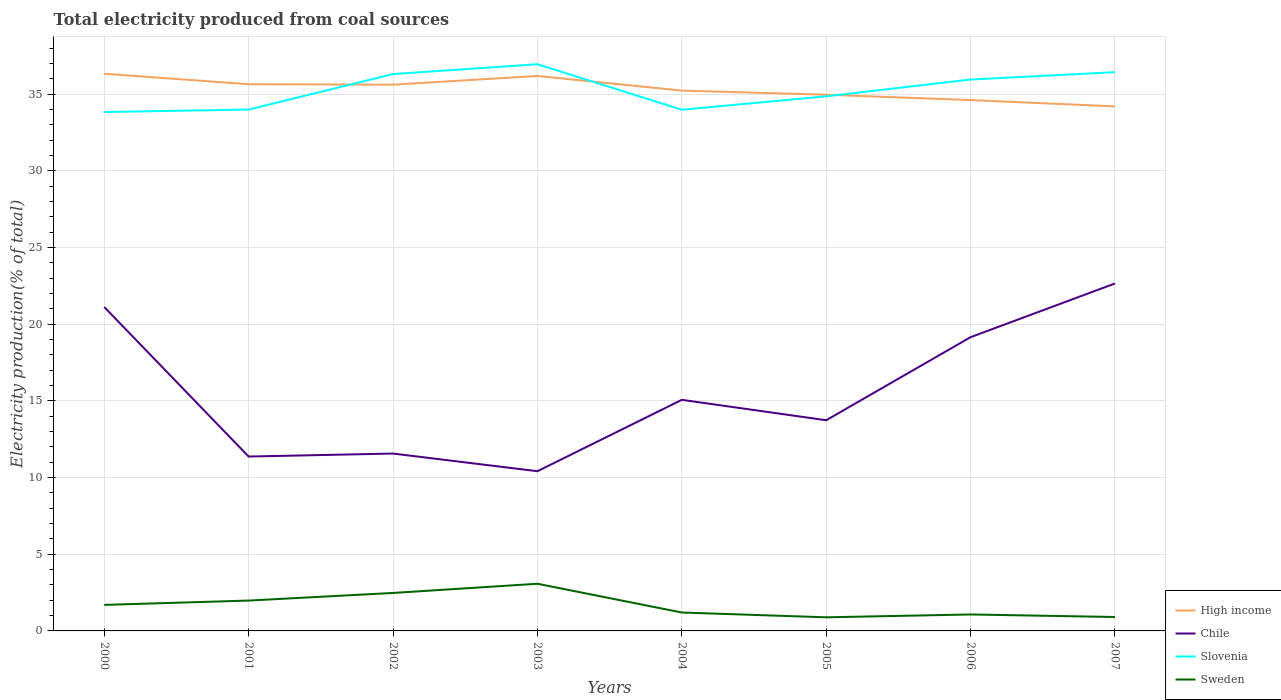Does the line corresponding to Chile intersect with the line corresponding to Sweden?
Ensure brevity in your answer.  No. Across all years, what is the maximum total electricity produced in Chile?
Your response must be concise. 10.42. In which year was the total electricity produced in Sweden maximum?
Your answer should be very brief. 2005. What is the total total electricity produced in Slovenia in the graph?
Provide a short and direct response. -1.97. What is the difference between the highest and the second highest total electricity produced in Chile?
Provide a short and direct response. 12.24. What is the difference between the highest and the lowest total electricity produced in Slovenia?
Provide a short and direct response. 4. Is the total electricity produced in Sweden strictly greater than the total electricity produced in Chile over the years?
Your answer should be very brief. Yes. Does the graph contain any zero values?
Provide a succinct answer. No. Where does the legend appear in the graph?
Your response must be concise. Bottom right. What is the title of the graph?
Provide a succinct answer. Total electricity produced from coal sources. Does "Uganda" appear as one of the legend labels in the graph?
Give a very brief answer. No. What is the Electricity production(% of total) of High income in 2000?
Provide a short and direct response. 36.34. What is the Electricity production(% of total) of Chile in 2000?
Make the answer very short. 21.13. What is the Electricity production(% of total) of Slovenia in 2000?
Your response must be concise. 33.84. What is the Electricity production(% of total) in Sweden in 2000?
Give a very brief answer. 1.7. What is the Electricity production(% of total) in High income in 2001?
Ensure brevity in your answer.  35.66. What is the Electricity production(% of total) of Chile in 2001?
Give a very brief answer. 11.37. What is the Electricity production(% of total) of Slovenia in 2001?
Your answer should be very brief. 34. What is the Electricity production(% of total) of Sweden in 2001?
Make the answer very short. 1.98. What is the Electricity production(% of total) in High income in 2002?
Give a very brief answer. 35.63. What is the Electricity production(% of total) of Chile in 2002?
Your answer should be compact. 11.57. What is the Electricity production(% of total) in Slovenia in 2002?
Make the answer very short. 36.32. What is the Electricity production(% of total) in Sweden in 2002?
Provide a succinct answer. 2.48. What is the Electricity production(% of total) in High income in 2003?
Your response must be concise. 36.2. What is the Electricity production(% of total) in Chile in 2003?
Offer a very short reply. 10.42. What is the Electricity production(% of total) of Slovenia in 2003?
Offer a very short reply. 36.96. What is the Electricity production(% of total) of Sweden in 2003?
Your answer should be compact. 3.08. What is the Electricity production(% of total) of High income in 2004?
Offer a terse response. 35.24. What is the Electricity production(% of total) in Chile in 2004?
Ensure brevity in your answer.  15.07. What is the Electricity production(% of total) of Slovenia in 2004?
Make the answer very short. 33.99. What is the Electricity production(% of total) in Sweden in 2004?
Keep it short and to the point. 1.2. What is the Electricity production(% of total) of High income in 2005?
Your response must be concise. 34.97. What is the Electricity production(% of total) of Chile in 2005?
Give a very brief answer. 13.74. What is the Electricity production(% of total) in Slovenia in 2005?
Your response must be concise. 34.87. What is the Electricity production(% of total) of Sweden in 2005?
Ensure brevity in your answer.  0.89. What is the Electricity production(% of total) in High income in 2006?
Your answer should be very brief. 34.62. What is the Electricity production(% of total) of Chile in 2006?
Offer a very short reply. 19.16. What is the Electricity production(% of total) of Slovenia in 2006?
Your answer should be very brief. 35.96. What is the Electricity production(% of total) of Sweden in 2006?
Give a very brief answer. 1.07. What is the Electricity production(% of total) in High income in 2007?
Provide a succinct answer. 34.21. What is the Electricity production(% of total) of Chile in 2007?
Provide a succinct answer. 22.66. What is the Electricity production(% of total) in Slovenia in 2007?
Give a very brief answer. 36.44. What is the Electricity production(% of total) of Sweden in 2007?
Your answer should be very brief. 0.91. Across all years, what is the maximum Electricity production(% of total) of High income?
Your response must be concise. 36.34. Across all years, what is the maximum Electricity production(% of total) of Chile?
Keep it short and to the point. 22.66. Across all years, what is the maximum Electricity production(% of total) of Slovenia?
Provide a short and direct response. 36.96. Across all years, what is the maximum Electricity production(% of total) in Sweden?
Offer a very short reply. 3.08. Across all years, what is the minimum Electricity production(% of total) in High income?
Make the answer very short. 34.21. Across all years, what is the minimum Electricity production(% of total) of Chile?
Your response must be concise. 10.42. Across all years, what is the minimum Electricity production(% of total) of Slovenia?
Your answer should be compact. 33.84. Across all years, what is the minimum Electricity production(% of total) of Sweden?
Ensure brevity in your answer.  0.89. What is the total Electricity production(% of total) of High income in the graph?
Keep it short and to the point. 282.87. What is the total Electricity production(% of total) in Chile in the graph?
Your response must be concise. 125.12. What is the total Electricity production(% of total) in Slovenia in the graph?
Give a very brief answer. 282.4. What is the total Electricity production(% of total) of Sweden in the graph?
Provide a succinct answer. 13.3. What is the difference between the Electricity production(% of total) of High income in 2000 and that in 2001?
Your answer should be compact. 0.68. What is the difference between the Electricity production(% of total) in Chile in 2000 and that in 2001?
Offer a very short reply. 9.75. What is the difference between the Electricity production(% of total) in Slovenia in 2000 and that in 2001?
Provide a succinct answer. -0.16. What is the difference between the Electricity production(% of total) in Sweden in 2000 and that in 2001?
Your answer should be very brief. -0.28. What is the difference between the Electricity production(% of total) in High income in 2000 and that in 2002?
Provide a succinct answer. 0.71. What is the difference between the Electricity production(% of total) in Chile in 2000 and that in 2002?
Your answer should be very brief. 9.56. What is the difference between the Electricity production(% of total) of Slovenia in 2000 and that in 2002?
Offer a very short reply. -2.48. What is the difference between the Electricity production(% of total) of Sweden in 2000 and that in 2002?
Provide a succinct answer. -0.78. What is the difference between the Electricity production(% of total) in High income in 2000 and that in 2003?
Provide a succinct answer. 0.14. What is the difference between the Electricity production(% of total) in Chile in 2000 and that in 2003?
Your answer should be compact. 10.71. What is the difference between the Electricity production(% of total) in Slovenia in 2000 and that in 2003?
Provide a short and direct response. -3.12. What is the difference between the Electricity production(% of total) of Sweden in 2000 and that in 2003?
Ensure brevity in your answer.  -1.38. What is the difference between the Electricity production(% of total) in High income in 2000 and that in 2004?
Your answer should be very brief. 1.1. What is the difference between the Electricity production(% of total) of Chile in 2000 and that in 2004?
Your response must be concise. 6.05. What is the difference between the Electricity production(% of total) in Slovenia in 2000 and that in 2004?
Provide a succinct answer. -0.15. What is the difference between the Electricity production(% of total) in Sweden in 2000 and that in 2004?
Your answer should be compact. 0.5. What is the difference between the Electricity production(% of total) in High income in 2000 and that in 2005?
Your response must be concise. 1.37. What is the difference between the Electricity production(% of total) in Chile in 2000 and that in 2005?
Make the answer very short. 7.38. What is the difference between the Electricity production(% of total) of Slovenia in 2000 and that in 2005?
Your response must be concise. -1.02. What is the difference between the Electricity production(% of total) of Sweden in 2000 and that in 2005?
Keep it short and to the point. 0.81. What is the difference between the Electricity production(% of total) in High income in 2000 and that in 2006?
Offer a very short reply. 1.72. What is the difference between the Electricity production(% of total) of Chile in 2000 and that in 2006?
Provide a succinct answer. 1.97. What is the difference between the Electricity production(% of total) of Slovenia in 2000 and that in 2006?
Your answer should be compact. -2.12. What is the difference between the Electricity production(% of total) in Sweden in 2000 and that in 2006?
Provide a short and direct response. 0.63. What is the difference between the Electricity production(% of total) of High income in 2000 and that in 2007?
Offer a terse response. 2.13. What is the difference between the Electricity production(% of total) of Chile in 2000 and that in 2007?
Give a very brief answer. -1.54. What is the difference between the Electricity production(% of total) in Slovenia in 2000 and that in 2007?
Provide a short and direct response. -2.6. What is the difference between the Electricity production(% of total) of Sweden in 2000 and that in 2007?
Ensure brevity in your answer.  0.79. What is the difference between the Electricity production(% of total) of High income in 2001 and that in 2002?
Keep it short and to the point. 0.03. What is the difference between the Electricity production(% of total) in Chile in 2001 and that in 2002?
Keep it short and to the point. -0.2. What is the difference between the Electricity production(% of total) in Slovenia in 2001 and that in 2002?
Provide a short and direct response. -2.32. What is the difference between the Electricity production(% of total) in Sweden in 2001 and that in 2002?
Keep it short and to the point. -0.5. What is the difference between the Electricity production(% of total) of High income in 2001 and that in 2003?
Offer a very short reply. -0.54. What is the difference between the Electricity production(% of total) of Chile in 2001 and that in 2003?
Ensure brevity in your answer.  0.96. What is the difference between the Electricity production(% of total) in Slovenia in 2001 and that in 2003?
Offer a terse response. -2.96. What is the difference between the Electricity production(% of total) of Sweden in 2001 and that in 2003?
Provide a short and direct response. -1.1. What is the difference between the Electricity production(% of total) in High income in 2001 and that in 2004?
Your answer should be very brief. 0.42. What is the difference between the Electricity production(% of total) in Chile in 2001 and that in 2004?
Keep it short and to the point. -3.7. What is the difference between the Electricity production(% of total) in Slovenia in 2001 and that in 2004?
Your answer should be very brief. 0.01. What is the difference between the Electricity production(% of total) of Sweden in 2001 and that in 2004?
Ensure brevity in your answer.  0.78. What is the difference between the Electricity production(% of total) in High income in 2001 and that in 2005?
Provide a succinct answer. 0.69. What is the difference between the Electricity production(% of total) in Chile in 2001 and that in 2005?
Your answer should be compact. -2.37. What is the difference between the Electricity production(% of total) in Slovenia in 2001 and that in 2005?
Ensure brevity in your answer.  -0.86. What is the difference between the Electricity production(% of total) of Sweden in 2001 and that in 2005?
Keep it short and to the point. 1.09. What is the difference between the Electricity production(% of total) of High income in 2001 and that in 2006?
Keep it short and to the point. 1.04. What is the difference between the Electricity production(% of total) of Chile in 2001 and that in 2006?
Your response must be concise. -7.79. What is the difference between the Electricity production(% of total) of Slovenia in 2001 and that in 2006?
Your response must be concise. -1.96. What is the difference between the Electricity production(% of total) of Sweden in 2001 and that in 2006?
Make the answer very short. 0.91. What is the difference between the Electricity production(% of total) in High income in 2001 and that in 2007?
Offer a very short reply. 1.45. What is the difference between the Electricity production(% of total) in Chile in 2001 and that in 2007?
Your response must be concise. -11.29. What is the difference between the Electricity production(% of total) of Slovenia in 2001 and that in 2007?
Your response must be concise. -2.44. What is the difference between the Electricity production(% of total) of Sweden in 2001 and that in 2007?
Offer a very short reply. 1.07. What is the difference between the Electricity production(% of total) in High income in 2002 and that in 2003?
Ensure brevity in your answer.  -0.57. What is the difference between the Electricity production(% of total) in Chile in 2002 and that in 2003?
Offer a terse response. 1.15. What is the difference between the Electricity production(% of total) of Slovenia in 2002 and that in 2003?
Provide a succinct answer. -0.64. What is the difference between the Electricity production(% of total) of Sweden in 2002 and that in 2003?
Offer a very short reply. -0.6. What is the difference between the Electricity production(% of total) in High income in 2002 and that in 2004?
Make the answer very short. 0.39. What is the difference between the Electricity production(% of total) in Chile in 2002 and that in 2004?
Ensure brevity in your answer.  -3.5. What is the difference between the Electricity production(% of total) in Slovenia in 2002 and that in 2004?
Your answer should be compact. 2.33. What is the difference between the Electricity production(% of total) in Sweden in 2002 and that in 2004?
Offer a terse response. 1.28. What is the difference between the Electricity production(% of total) of High income in 2002 and that in 2005?
Keep it short and to the point. 0.66. What is the difference between the Electricity production(% of total) of Chile in 2002 and that in 2005?
Ensure brevity in your answer.  -2.17. What is the difference between the Electricity production(% of total) of Slovenia in 2002 and that in 2005?
Your answer should be compact. 1.45. What is the difference between the Electricity production(% of total) in Sweden in 2002 and that in 2005?
Your response must be concise. 1.59. What is the difference between the Electricity production(% of total) of High income in 2002 and that in 2006?
Keep it short and to the point. 1. What is the difference between the Electricity production(% of total) of Chile in 2002 and that in 2006?
Provide a succinct answer. -7.59. What is the difference between the Electricity production(% of total) of Slovenia in 2002 and that in 2006?
Keep it short and to the point. 0.36. What is the difference between the Electricity production(% of total) in Sweden in 2002 and that in 2006?
Keep it short and to the point. 1.4. What is the difference between the Electricity production(% of total) in High income in 2002 and that in 2007?
Provide a short and direct response. 1.42. What is the difference between the Electricity production(% of total) of Chile in 2002 and that in 2007?
Ensure brevity in your answer.  -11.09. What is the difference between the Electricity production(% of total) in Slovenia in 2002 and that in 2007?
Your response must be concise. -0.12. What is the difference between the Electricity production(% of total) in Sweden in 2002 and that in 2007?
Your answer should be very brief. 1.57. What is the difference between the Electricity production(% of total) of High income in 2003 and that in 2004?
Ensure brevity in your answer.  0.95. What is the difference between the Electricity production(% of total) of Chile in 2003 and that in 2004?
Make the answer very short. -4.66. What is the difference between the Electricity production(% of total) of Slovenia in 2003 and that in 2004?
Keep it short and to the point. 2.97. What is the difference between the Electricity production(% of total) of Sweden in 2003 and that in 2004?
Provide a short and direct response. 1.88. What is the difference between the Electricity production(% of total) of High income in 2003 and that in 2005?
Your answer should be very brief. 1.22. What is the difference between the Electricity production(% of total) of Chile in 2003 and that in 2005?
Make the answer very short. -3.32. What is the difference between the Electricity production(% of total) in Slovenia in 2003 and that in 2005?
Ensure brevity in your answer.  2.09. What is the difference between the Electricity production(% of total) in Sweden in 2003 and that in 2005?
Your answer should be very brief. 2.19. What is the difference between the Electricity production(% of total) of High income in 2003 and that in 2006?
Ensure brevity in your answer.  1.57. What is the difference between the Electricity production(% of total) of Chile in 2003 and that in 2006?
Offer a very short reply. -8.74. What is the difference between the Electricity production(% of total) of Slovenia in 2003 and that in 2006?
Offer a very short reply. 1. What is the difference between the Electricity production(% of total) of Sweden in 2003 and that in 2006?
Provide a short and direct response. 2. What is the difference between the Electricity production(% of total) of High income in 2003 and that in 2007?
Give a very brief answer. 1.99. What is the difference between the Electricity production(% of total) of Chile in 2003 and that in 2007?
Offer a very short reply. -12.24. What is the difference between the Electricity production(% of total) of Slovenia in 2003 and that in 2007?
Offer a very short reply. 0.52. What is the difference between the Electricity production(% of total) in Sweden in 2003 and that in 2007?
Provide a short and direct response. 2.17. What is the difference between the Electricity production(% of total) of High income in 2004 and that in 2005?
Your answer should be very brief. 0.27. What is the difference between the Electricity production(% of total) in Chile in 2004 and that in 2005?
Your response must be concise. 1.33. What is the difference between the Electricity production(% of total) of Slovenia in 2004 and that in 2005?
Provide a succinct answer. -0.88. What is the difference between the Electricity production(% of total) of Sweden in 2004 and that in 2005?
Your response must be concise. 0.31. What is the difference between the Electricity production(% of total) in High income in 2004 and that in 2006?
Provide a short and direct response. 0.62. What is the difference between the Electricity production(% of total) in Chile in 2004 and that in 2006?
Ensure brevity in your answer.  -4.09. What is the difference between the Electricity production(% of total) of Slovenia in 2004 and that in 2006?
Provide a succinct answer. -1.97. What is the difference between the Electricity production(% of total) of Sweden in 2004 and that in 2006?
Your answer should be very brief. 0.13. What is the difference between the Electricity production(% of total) of High income in 2004 and that in 2007?
Give a very brief answer. 1.03. What is the difference between the Electricity production(% of total) of Chile in 2004 and that in 2007?
Make the answer very short. -7.59. What is the difference between the Electricity production(% of total) of Slovenia in 2004 and that in 2007?
Provide a succinct answer. -2.45. What is the difference between the Electricity production(% of total) of Sweden in 2004 and that in 2007?
Provide a short and direct response. 0.29. What is the difference between the Electricity production(% of total) of High income in 2005 and that in 2006?
Your answer should be compact. 0.35. What is the difference between the Electricity production(% of total) of Chile in 2005 and that in 2006?
Your response must be concise. -5.42. What is the difference between the Electricity production(% of total) of Slovenia in 2005 and that in 2006?
Give a very brief answer. -1.1. What is the difference between the Electricity production(% of total) of Sweden in 2005 and that in 2006?
Offer a terse response. -0.19. What is the difference between the Electricity production(% of total) of High income in 2005 and that in 2007?
Provide a succinct answer. 0.76. What is the difference between the Electricity production(% of total) of Chile in 2005 and that in 2007?
Offer a very short reply. -8.92. What is the difference between the Electricity production(% of total) in Slovenia in 2005 and that in 2007?
Your answer should be very brief. -1.57. What is the difference between the Electricity production(% of total) of Sweden in 2005 and that in 2007?
Provide a short and direct response. -0.02. What is the difference between the Electricity production(% of total) in High income in 2006 and that in 2007?
Make the answer very short. 0.41. What is the difference between the Electricity production(% of total) of Chile in 2006 and that in 2007?
Keep it short and to the point. -3.5. What is the difference between the Electricity production(% of total) of Slovenia in 2006 and that in 2007?
Ensure brevity in your answer.  -0.48. What is the difference between the Electricity production(% of total) in Sweden in 2006 and that in 2007?
Keep it short and to the point. 0.17. What is the difference between the Electricity production(% of total) of High income in 2000 and the Electricity production(% of total) of Chile in 2001?
Provide a succinct answer. 24.97. What is the difference between the Electricity production(% of total) in High income in 2000 and the Electricity production(% of total) in Slovenia in 2001?
Your answer should be compact. 2.34. What is the difference between the Electricity production(% of total) of High income in 2000 and the Electricity production(% of total) of Sweden in 2001?
Provide a succinct answer. 34.36. What is the difference between the Electricity production(% of total) in Chile in 2000 and the Electricity production(% of total) in Slovenia in 2001?
Your response must be concise. -12.88. What is the difference between the Electricity production(% of total) of Chile in 2000 and the Electricity production(% of total) of Sweden in 2001?
Make the answer very short. 19.15. What is the difference between the Electricity production(% of total) of Slovenia in 2000 and the Electricity production(% of total) of Sweden in 2001?
Your response must be concise. 31.86. What is the difference between the Electricity production(% of total) in High income in 2000 and the Electricity production(% of total) in Chile in 2002?
Your answer should be very brief. 24.77. What is the difference between the Electricity production(% of total) in High income in 2000 and the Electricity production(% of total) in Slovenia in 2002?
Provide a succinct answer. 0.02. What is the difference between the Electricity production(% of total) in High income in 2000 and the Electricity production(% of total) in Sweden in 2002?
Ensure brevity in your answer.  33.86. What is the difference between the Electricity production(% of total) of Chile in 2000 and the Electricity production(% of total) of Slovenia in 2002?
Provide a short and direct response. -15.19. What is the difference between the Electricity production(% of total) in Chile in 2000 and the Electricity production(% of total) in Sweden in 2002?
Provide a short and direct response. 18.65. What is the difference between the Electricity production(% of total) of Slovenia in 2000 and the Electricity production(% of total) of Sweden in 2002?
Your answer should be compact. 31.37. What is the difference between the Electricity production(% of total) in High income in 2000 and the Electricity production(% of total) in Chile in 2003?
Your answer should be compact. 25.92. What is the difference between the Electricity production(% of total) of High income in 2000 and the Electricity production(% of total) of Slovenia in 2003?
Your response must be concise. -0.62. What is the difference between the Electricity production(% of total) of High income in 2000 and the Electricity production(% of total) of Sweden in 2003?
Your answer should be compact. 33.26. What is the difference between the Electricity production(% of total) of Chile in 2000 and the Electricity production(% of total) of Slovenia in 2003?
Your answer should be very brief. -15.83. What is the difference between the Electricity production(% of total) of Chile in 2000 and the Electricity production(% of total) of Sweden in 2003?
Your answer should be compact. 18.05. What is the difference between the Electricity production(% of total) of Slovenia in 2000 and the Electricity production(% of total) of Sweden in 2003?
Your answer should be very brief. 30.77. What is the difference between the Electricity production(% of total) of High income in 2000 and the Electricity production(% of total) of Chile in 2004?
Make the answer very short. 21.27. What is the difference between the Electricity production(% of total) in High income in 2000 and the Electricity production(% of total) in Slovenia in 2004?
Make the answer very short. 2.35. What is the difference between the Electricity production(% of total) of High income in 2000 and the Electricity production(% of total) of Sweden in 2004?
Provide a succinct answer. 35.14. What is the difference between the Electricity production(% of total) of Chile in 2000 and the Electricity production(% of total) of Slovenia in 2004?
Keep it short and to the point. -12.87. What is the difference between the Electricity production(% of total) of Chile in 2000 and the Electricity production(% of total) of Sweden in 2004?
Ensure brevity in your answer.  19.93. What is the difference between the Electricity production(% of total) in Slovenia in 2000 and the Electricity production(% of total) in Sweden in 2004?
Offer a terse response. 32.64. What is the difference between the Electricity production(% of total) of High income in 2000 and the Electricity production(% of total) of Chile in 2005?
Offer a very short reply. 22.6. What is the difference between the Electricity production(% of total) of High income in 2000 and the Electricity production(% of total) of Slovenia in 2005?
Ensure brevity in your answer.  1.47. What is the difference between the Electricity production(% of total) of High income in 2000 and the Electricity production(% of total) of Sweden in 2005?
Make the answer very short. 35.45. What is the difference between the Electricity production(% of total) in Chile in 2000 and the Electricity production(% of total) in Slovenia in 2005?
Give a very brief answer. -13.74. What is the difference between the Electricity production(% of total) of Chile in 2000 and the Electricity production(% of total) of Sweden in 2005?
Keep it short and to the point. 20.24. What is the difference between the Electricity production(% of total) in Slovenia in 2000 and the Electricity production(% of total) in Sweden in 2005?
Ensure brevity in your answer.  32.96. What is the difference between the Electricity production(% of total) of High income in 2000 and the Electricity production(% of total) of Chile in 2006?
Ensure brevity in your answer.  17.18. What is the difference between the Electricity production(% of total) in High income in 2000 and the Electricity production(% of total) in Slovenia in 2006?
Your response must be concise. 0.38. What is the difference between the Electricity production(% of total) of High income in 2000 and the Electricity production(% of total) of Sweden in 2006?
Your answer should be compact. 35.27. What is the difference between the Electricity production(% of total) of Chile in 2000 and the Electricity production(% of total) of Slovenia in 2006?
Your response must be concise. -14.84. What is the difference between the Electricity production(% of total) in Chile in 2000 and the Electricity production(% of total) in Sweden in 2006?
Offer a terse response. 20.05. What is the difference between the Electricity production(% of total) in Slovenia in 2000 and the Electricity production(% of total) in Sweden in 2006?
Provide a succinct answer. 32.77. What is the difference between the Electricity production(% of total) of High income in 2000 and the Electricity production(% of total) of Chile in 2007?
Offer a terse response. 13.68. What is the difference between the Electricity production(% of total) in High income in 2000 and the Electricity production(% of total) in Slovenia in 2007?
Make the answer very short. -0.1. What is the difference between the Electricity production(% of total) of High income in 2000 and the Electricity production(% of total) of Sweden in 2007?
Provide a short and direct response. 35.43. What is the difference between the Electricity production(% of total) of Chile in 2000 and the Electricity production(% of total) of Slovenia in 2007?
Keep it short and to the point. -15.32. What is the difference between the Electricity production(% of total) of Chile in 2000 and the Electricity production(% of total) of Sweden in 2007?
Provide a short and direct response. 20.22. What is the difference between the Electricity production(% of total) in Slovenia in 2000 and the Electricity production(% of total) in Sweden in 2007?
Provide a short and direct response. 32.94. What is the difference between the Electricity production(% of total) in High income in 2001 and the Electricity production(% of total) in Chile in 2002?
Offer a terse response. 24.09. What is the difference between the Electricity production(% of total) of High income in 2001 and the Electricity production(% of total) of Slovenia in 2002?
Make the answer very short. -0.66. What is the difference between the Electricity production(% of total) of High income in 2001 and the Electricity production(% of total) of Sweden in 2002?
Offer a very short reply. 33.18. What is the difference between the Electricity production(% of total) in Chile in 2001 and the Electricity production(% of total) in Slovenia in 2002?
Make the answer very short. -24.95. What is the difference between the Electricity production(% of total) in Chile in 2001 and the Electricity production(% of total) in Sweden in 2002?
Your answer should be compact. 8.9. What is the difference between the Electricity production(% of total) in Slovenia in 2001 and the Electricity production(% of total) in Sweden in 2002?
Provide a succinct answer. 31.53. What is the difference between the Electricity production(% of total) in High income in 2001 and the Electricity production(% of total) in Chile in 2003?
Give a very brief answer. 25.24. What is the difference between the Electricity production(% of total) of High income in 2001 and the Electricity production(% of total) of Slovenia in 2003?
Keep it short and to the point. -1.3. What is the difference between the Electricity production(% of total) in High income in 2001 and the Electricity production(% of total) in Sweden in 2003?
Ensure brevity in your answer.  32.58. What is the difference between the Electricity production(% of total) in Chile in 2001 and the Electricity production(% of total) in Slovenia in 2003?
Provide a short and direct response. -25.59. What is the difference between the Electricity production(% of total) of Chile in 2001 and the Electricity production(% of total) of Sweden in 2003?
Keep it short and to the point. 8.3. What is the difference between the Electricity production(% of total) in Slovenia in 2001 and the Electricity production(% of total) in Sweden in 2003?
Give a very brief answer. 30.93. What is the difference between the Electricity production(% of total) of High income in 2001 and the Electricity production(% of total) of Chile in 2004?
Keep it short and to the point. 20.59. What is the difference between the Electricity production(% of total) of High income in 2001 and the Electricity production(% of total) of Slovenia in 2004?
Your answer should be compact. 1.67. What is the difference between the Electricity production(% of total) of High income in 2001 and the Electricity production(% of total) of Sweden in 2004?
Offer a terse response. 34.46. What is the difference between the Electricity production(% of total) in Chile in 2001 and the Electricity production(% of total) in Slovenia in 2004?
Your response must be concise. -22.62. What is the difference between the Electricity production(% of total) in Chile in 2001 and the Electricity production(% of total) in Sweden in 2004?
Provide a short and direct response. 10.17. What is the difference between the Electricity production(% of total) in Slovenia in 2001 and the Electricity production(% of total) in Sweden in 2004?
Your response must be concise. 32.8. What is the difference between the Electricity production(% of total) of High income in 2001 and the Electricity production(% of total) of Chile in 2005?
Provide a succinct answer. 21.92. What is the difference between the Electricity production(% of total) of High income in 2001 and the Electricity production(% of total) of Slovenia in 2005?
Ensure brevity in your answer.  0.79. What is the difference between the Electricity production(% of total) in High income in 2001 and the Electricity production(% of total) in Sweden in 2005?
Provide a succinct answer. 34.77. What is the difference between the Electricity production(% of total) of Chile in 2001 and the Electricity production(% of total) of Slovenia in 2005?
Provide a succinct answer. -23.5. What is the difference between the Electricity production(% of total) of Chile in 2001 and the Electricity production(% of total) of Sweden in 2005?
Keep it short and to the point. 10.49. What is the difference between the Electricity production(% of total) of Slovenia in 2001 and the Electricity production(% of total) of Sweden in 2005?
Offer a very short reply. 33.12. What is the difference between the Electricity production(% of total) of High income in 2001 and the Electricity production(% of total) of Chile in 2006?
Provide a succinct answer. 16.5. What is the difference between the Electricity production(% of total) of High income in 2001 and the Electricity production(% of total) of Slovenia in 2006?
Make the answer very short. -0.31. What is the difference between the Electricity production(% of total) in High income in 2001 and the Electricity production(% of total) in Sweden in 2006?
Provide a succinct answer. 34.59. What is the difference between the Electricity production(% of total) in Chile in 2001 and the Electricity production(% of total) in Slovenia in 2006?
Keep it short and to the point. -24.59. What is the difference between the Electricity production(% of total) in Chile in 2001 and the Electricity production(% of total) in Sweden in 2006?
Make the answer very short. 10.3. What is the difference between the Electricity production(% of total) of Slovenia in 2001 and the Electricity production(% of total) of Sweden in 2006?
Your answer should be compact. 32.93. What is the difference between the Electricity production(% of total) in High income in 2001 and the Electricity production(% of total) in Chile in 2007?
Offer a very short reply. 13. What is the difference between the Electricity production(% of total) of High income in 2001 and the Electricity production(% of total) of Slovenia in 2007?
Offer a terse response. -0.78. What is the difference between the Electricity production(% of total) in High income in 2001 and the Electricity production(% of total) in Sweden in 2007?
Give a very brief answer. 34.75. What is the difference between the Electricity production(% of total) in Chile in 2001 and the Electricity production(% of total) in Slovenia in 2007?
Your answer should be very brief. -25.07. What is the difference between the Electricity production(% of total) of Chile in 2001 and the Electricity production(% of total) of Sweden in 2007?
Provide a short and direct response. 10.47. What is the difference between the Electricity production(% of total) in Slovenia in 2001 and the Electricity production(% of total) in Sweden in 2007?
Keep it short and to the point. 33.1. What is the difference between the Electricity production(% of total) of High income in 2002 and the Electricity production(% of total) of Chile in 2003?
Your answer should be very brief. 25.21. What is the difference between the Electricity production(% of total) in High income in 2002 and the Electricity production(% of total) in Slovenia in 2003?
Make the answer very short. -1.33. What is the difference between the Electricity production(% of total) of High income in 2002 and the Electricity production(% of total) of Sweden in 2003?
Keep it short and to the point. 32.55. What is the difference between the Electricity production(% of total) in Chile in 2002 and the Electricity production(% of total) in Slovenia in 2003?
Keep it short and to the point. -25.39. What is the difference between the Electricity production(% of total) of Chile in 2002 and the Electricity production(% of total) of Sweden in 2003?
Your answer should be compact. 8.49. What is the difference between the Electricity production(% of total) in Slovenia in 2002 and the Electricity production(% of total) in Sweden in 2003?
Offer a terse response. 33.24. What is the difference between the Electricity production(% of total) in High income in 2002 and the Electricity production(% of total) in Chile in 2004?
Your response must be concise. 20.56. What is the difference between the Electricity production(% of total) of High income in 2002 and the Electricity production(% of total) of Slovenia in 2004?
Ensure brevity in your answer.  1.63. What is the difference between the Electricity production(% of total) in High income in 2002 and the Electricity production(% of total) in Sweden in 2004?
Offer a very short reply. 34.43. What is the difference between the Electricity production(% of total) of Chile in 2002 and the Electricity production(% of total) of Slovenia in 2004?
Keep it short and to the point. -22.42. What is the difference between the Electricity production(% of total) of Chile in 2002 and the Electricity production(% of total) of Sweden in 2004?
Give a very brief answer. 10.37. What is the difference between the Electricity production(% of total) in Slovenia in 2002 and the Electricity production(% of total) in Sweden in 2004?
Keep it short and to the point. 35.12. What is the difference between the Electricity production(% of total) of High income in 2002 and the Electricity production(% of total) of Chile in 2005?
Your response must be concise. 21.89. What is the difference between the Electricity production(% of total) in High income in 2002 and the Electricity production(% of total) in Slovenia in 2005?
Provide a succinct answer. 0.76. What is the difference between the Electricity production(% of total) in High income in 2002 and the Electricity production(% of total) in Sweden in 2005?
Make the answer very short. 34.74. What is the difference between the Electricity production(% of total) in Chile in 2002 and the Electricity production(% of total) in Slovenia in 2005?
Make the answer very short. -23.3. What is the difference between the Electricity production(% of total) of Chile in 2002 and the Electricity production(% of total) of Sweden in 2005?
Your answer should be compact. 10.68. What is the difference between the Electricity production(% of total) in Slovenia in 2002 and the Electricity production(% of total) in Sweden in 2005?
Your response must be concise. 35.43. What is the difference between the Electricity production(% of total) in High income in 2002 and the Electricity production(% of total) in Chile in 2006?
Provide a short and direct response. 16.47. What is the difference between the Electricity production(% of total) in High income in 2002 and the Electricity production(% of total) in Slovenia in 2006?
Your answer should be very brief. -0.34. What is the difference between the Electricity production(% of total) of High income in 2002 and the Electricity production(% of total) of Sweden in 2006?
Keep it short and to the point. 34.55. What is the difference between the Electricity production(% of total) in Chile in 2002 and the Electricity production(% of total) in Slovenia in 2006?
Provide a short and direct response. -24.4. What is the difference between the Electricity production(% of total) in Chile in 2002 and the Electricity production(% of total) in Sweden in 2006?
Offer a very short reply. 10.5. What is the difference between the Electricity production(% of total) in Slovenia in 2002 and the Electricity production(% of total) in Sweden in 2006?
Offer a very short reply. 35.25. What is the difference between the Electricity production(% of total) in High income in 2002 and the Electricity production(% of total) in Chile in 2007?
Provide a succinct answer. 12.97. What is the difference between the Electricity production(% of total) of High income in 2002 and the Electricity production(% of total) of Slovenia in 2007?
Your answer should be compact. -0.82. What is the difference between the Electricity production(% of total) of High income in 2002 and the Electricity production(% of total) of Sweden in 2007?
Your response must be concise. 34.72. What is the difference between the Electricity production(% of total) of Chile in 2002 and the Electricity production(% of total) of Slovenia in 2007?
Your answer should be very brief. -24.87. What is the difference between the Electricity production(% of total) of Chile in 2002 and the Electricity production(% of total) of Sweden in 2007?
Your answer should be very brief. 10.66. What is the difference between the Electricity production(% of total) in Slovenia in 2002 and the Electricity production(% of total) in Sweden in 2007?
Offer a terse response. 35.41. What is the difference between the Electricity production(% of total) of High income in 2003 and the Electricity production(% of total) of Chile in 2004?
Provide a short and direct response. 21.12. What is the difference between the Electricity production(% of total) in High income in 2003 and the Electricity production(% of total) in Slovenia in 2004?
Make the answer very short. 2.2. What is the difference between the Electricity production(% of total) in High income in 2003 and the Electricity production(% of total) in Sweden in 2004?
Offer a very short reply. 35. What is the difference between the Electricity production(% of total) in Chile in 2003 and the Electricity production(% of total) in Slovenia in 2004?
Provide a succinct answer. -23.58. What is the difference between the Electricity production(% of total) in Chile in 2003 and the Electricity production(% of total) in Sweden in 2004?
Your response must be concise. 9.22. What is the difference between the Electricity production(% of total) in Slovenia in 2003 and the Electricity production(% of total) in Sweden in 2004?
Your answer should be compact. 35.76. What is the difference between the Electricity production(% of total) of High income in 2003 and the Electricity production(% of total) of Chile in 2005?
Offer a very short reply. 22.45. What is the difference between the Electricity production(% of total) of High income in 2003 and the Electricity production(% of total) of Slovenia in 2005?
Offer a terse response. 1.33. What is the difference between the Electricity production(% of total) in High income in 2003 and the Electricity production(% of total) in Sweden in 2005?
Offer a very short reply. 35.31. What is the difference between the Electricity production(% of total) in Chile in 2003 and the Electricity production(% of total) in Slovenia in 2005?
Keep it short and to the point. -24.45. What is the difference between the Electricity production(% of total) of Chile in 2003 and the Electricity production(% of total) of Sweden in 2005?
Ensure brevity in your answer.  9.53. What is the difference between the Electricity production(% of total) of Slovenia in 2003 and the Electricity production(% of total) of Sweden in 2005?
Give a very brief answer. 36.07. What is the difference between the Electricity production(% of total) in High income in 2003 and the Electricity production(% of total) in Chile in 2006?
Ensure brevity in your answer.  17.04. What is the difference between the Electricity production(% of total) in High income in 2003 and the Electricity production(% of total) in Slovenia in 2006?
Give a very brief answer. 0.23. What is the difference between the Electricity production(% of total) of High income in 2003 and the Electricity production(% of total) of Sweden in 2006?
Your response must be concise. 35.12. What is the difference between the Electricity production(% of total) of Chile in 2003 and the Electricity production(% of total) of Slovenia in 2006?
Keep it short and to the point. -25.55. What is the difference between the Electricity production(% of total) of Chile in 2003 and the Electricity production(% of total) of Sweden in 2006?
Give a very brief answer. 9.34. What is the difference between the Electricity production(% of total) of Slovenia in 2003 and the Electricity production(% of total) of Sweden in 2006?
Make the answer very short. 35.89. What is the difference between the Electricity production(% of total) of High income in 2003 and the Electricity production(% of total) of Chile in 2007?
Provide a succinct answer. 13.53. What is the difference between the Electricity production(% of total) of High income in 2003 and the Electricity production(% of total) of Slovenia in 2007?
Offer a very short reply. -0.25. What is the difference between the Electricity production(% of total) in High income in 2003 and the Electricity production(% of total) in Sweden in 2007?
Your response must be concise. 35.29. What is the difference between the Electricity production(% of total) in Chile in 2003 and the Electricity production(% of total) in Slovenia in 2007?
Provide a succinct answer. -26.03. What is the difference between the Electricity production(% of total) of Chile in 2003 and the Electricity production(% of total) of Sweden in 2007?
Your answer should be very brief. 9.51. What is the difference between the Electricity production(% of total) of Slovenia in 2003 and the Electricity production(% of total) of Sweden in 2007?
Give a very brief answer. 36.05. What is the difference between the Electricity production(% of total) of High income in 2004 and the Electricity production(% of total) of Chile in 2005?
Your answer should be compact. 21.5. What is the difference between the Electricity production(% of total) in High income in 2004 and the Electricity production(% of total) in Slovenia in 2005?
Keep it short and to the point. 0.37. What is the difference between the Electricity production(% of total) in High income in 2004 and the Electricity production(% of total) in Sweden in 2005?
Ensure brevity in your answer.  34.35. What is the difference between the Electricity production(% of total) in Chile in 2004 and the Electricity production(% of total) in Slovenia in 2005?
Provide a short and direct response. -19.8. What is the difference between the Electricity production(% of total) of Chile in 2004 and the Electricity production(% of total) of Sweden in 2005?
Your answer should be compact. 14.18. What is the difference between the Electricity production(% of total) in Slovenia in 2004 and the Electricity production(% of total) in Sweden in 2005?
Give a very brief answer. 33.11. What is the difference between the Electricity production(% of total) in High income in 2004 and the Electricity production(% of total) in Chile in 2006?
Provide a succinct answer. 16.08. What is the difference between the Electricity production(% of total) of High income in 2004 and the Electricity production(% of total) of Slovenia in 2006?
Your answer should be compact. -0.72. What is the difference between the Electricity production(% of total) in High income in 2004 and the Electricity production(% of total) in Sweden in 2006?
Your answer should be very brief. 34.17. What is the difference between the Electricity production(% of total) in Chile in 2004 and the Electricity production(% of total) in Slovenia in 2006?
Provide a short and direct response. -20.89. What is the difference between the Electricity production(% of total) in Chile in 2004 and the Electricity production(% of total) in Sweden in 2006?
Give a very brief answer. 14. What is the difference between the Electricity production(% of total) of Slovenia in 2004 and the Electricity production(% of total) of Sweden in 2006?
Keep it short and to the point. 32.92. What is the difference between the Electricity production(% of total) in High income in 2004 and the Electricity production(% of total) in Chile in 2007?
Your answer should be compact. 12.58. What is the difference between the Electricity production(% of total) of High income in 2004 and the Electricity production(% of total) of Slovenia in 2007?
Give a very brief answer. -1.2. What is the difference between the Electricity production(% of total) in High income in 2004 and the Electricity production(% of total) in Sweden in 2007?
Offer a terse response. 34.33. What is the difference between the Electricity production(% of total) in Chile in 2004 and the Electricity production(% of total) in Slovenia in 2007?
Make the answer very short. -21.37. What is the difference between the Electricity production(% of total) of Chile in 2004 and the Electricity production(% of total) of Sweden in 2007?
Offer a very short reply. 14.16. What is the difference between the Electricity production(% of total) in Slovenia in 2004 and the Electricity production(% of total) in Sweden in 2007?
Offer a very short reply. 33.09. What is the difference between the Electricity production(% of total) in High income in 2005 and the Electricity production(% of total) in Chile in 2006?
Ensure brevity in your answer.  15.81. What is the difference between the Electricity production(% of total) in High income in 2005 and the Electricity production(% of total) in Slovenia in 2006?
Your answer should be very brief. -0.99. What is the difference between the Electricity production(% of total) in High income in 2005 and the Electricity production(% of total) in Sweden in 2006?
Offer a terse response. 33.9. What is the difference between the Electricity production(% of total) in Chile in 2005 and the Electricity production(% of total) in Slovenia in 2006?
Give a very brief answer. -22.22. What is the difference between the Electricity production(% of total) in Chile in 2005 and the Electricity production(% of total) in Sweden in 2006?
Your answer should be compact. 12.67. What is the difference between the Electricity production(% of total) in Slovenia in 2005 and the Electricity production(% of total) in Sweden in 2006?
Your answer should be compact. 33.8. What is the difference between the Electricity production(% of total) of High income in 2005 and the Electricity production(% of total) of Chile in 2007?
Make the answer very short. 12.31. What is the difference between the Electricity production(% of total) in High income in 2005 and the Electricity production(% of total) in Slovenia in 2007?
Offer a terse response. -1.47. What is the difference between the Electricity production(% of total) in High income in 2005 and the Electricity production(% of total) in Sweden in 2007?
Offer a very short reply. 34.06. What is the difference between the Electricity production(% of total) in Chile in 2005 and the Electricity production(% of total) in Slovenia in 2007?
Offer a very short reply. -22.7. What is the difference between the Electricity production(% of total) of Chile in 2005 and the Electricity production(% of total) of Sweden in 2007?
Offer a terse response. 12.83. What is the difference between the Electricity production(% of total) in Slovenia in 2005 and the Electricity production(% of total) in Sweden in 2007?
Keep it short and to the point. 33.96. What is the difference between the Electricity production(% of total) of High income in 2006 and the Electricity production(% of total) of Chile in 2007?
Your answer should be compact. 11.96. What is the difference between the Electricity production(% of total) in High income in 2006 and the Electricity production(% of total) in Slovenia in 2007?
Make the answer very short. -1.82. What is the difference between the Electricity production(% of total) in High income in 2006 and the Electricity production(% of total) in Sweden in 2007?
Keep it short and to the point. 33.72. What is the difference between the Electricity production(% of total) of Chile in 2006 and the Electricity production(% of total) of Slovenia in 2007?
Provide a short and direct response. -17.28. What is the difference between the Electricity production(% of total) of Chile in 2006 and the Electricity production(% of total) of Sweden in 2007?
Offer a terse response. 18.25. What is the difference between the Electricity production(% of total) in Slovenia in 2006 and the Electricity production(% of total) in Sweden in 2007?
Provide a succinct answer. 35.06. What is the average Electricity production(% of total) of High income per year?
Ensure brevity in your answer.  35.36. What is the average Electricity production(% of total) in Chile per year?
Ensure brevity in your answer.  15.64. What is the average Electricity production(% of total) in Slovenia per year?
Offer a very short reply. 35.3. What is the average Electricity production(% of total) in Sweden per year?
Offer a very short reply. 1.66. In the year 2000, what is the difference between the Electricity production(% of total) in High income and Electricity production(% of total) in Chile?
Make the answer very short. 15.21. In the year 2000, what is the difference between the Electricity production(% of total) of High income and Electricity production(% of total) of Slovenia?
Keep it short and to the point. 2.49. In the year 2000, what is the difference between the Electricity production(% of total) of High income and Electricity production(% of total) of Sweden?
Ensure brevity in your answer.  34.64. In the year 2000, what is the difference between the Electricity production(% of total) of Chile and Electricity production(% of total) of Slovenia?
Offer a very short reply. -12.72. In the year 2000, what is the difference between the Electricity production(% of total) of Chile and Electricity production(% of total) of Sweden?
Offer a very short reply. 19.43. In the year 2000, what is the difference between the Electricity production(% of total) in Slovenia and Electricity production(% of total) in Sweden?
Your response must be concise. 32.15. In the year 2001, what is the difference between the Electricity production(% of total) in High income and Electricity production(% of total) in Chile?
Your response must be concise. 24.29. In the year 2001, what is the difference between the Electricity production(% of total) of High income and Electricity production(% of total) of Slovenia?
Offer a terse response. 1.65. In the year 2001, what is the difference between the Electricity production(% of total) of High income and Electricity production(% of total) of Sweden?
Provide a succinct answer. 33.68. In the year 2001, what is the difference between the Electricity production(% of total) of Chile and Electricity production(% of total) of Slovenia?
Give a very brief answer. -22.63. In the year 2001, what is the difference between the Electricity production(% of total) in Chile and Electricity production(% of total) in Sweden?
Your answer should be very brief. 9.39. In the year 2001, what is the difference between the Electricity production(% of total) in Slovenia and Electricity production(% of total) in Sweden?
Provide a short and direct response. 32.02. In the year 2002, what is the difference between the Electricity production(% of total) in High income and Electricity production(% of total) in Chile?
Offer a very short reply. 24.06. In the year 2002, what is the difference between the Electricity production(% of total) in High income and Electricity production(% of total) in Slovenia?
Your response must be concise. -0.69. In the year 2002, what is the difference between the Electricity production(% of total) of High income and Electricity production(% of total) of Sweden?
Keep it short and to the point. 33.15. In the year 2002, what is the difference between the Electricity production(% of total) in Chile and Electricity production(% of total) in Slovenia?
Your answer should be compact. -24.75. In the year 2002, what is the difference between the Electricity production(% of total) of Chile and Electricity production(% of total) of Sweden?
Give a very brief answer. 9.09. In the year 2002, what is the difference between the Electricity production(% of total) of Slovenia and Electricity production(% of total) of Sweden?
Give a very brief answer. 33.84. In the year 2003, what is the difference between the Electricity production(% of total) in High income and Electricity production(% of total) in Chile?
Offer a terse response. 25.78. In the year 2003, what is the difference between the Electricity production(% of total) in High income and Electricity production(% of total) in Slovenia?
Give a very brief answer. -0.76. In the year 2003, what is the difference between the Electricity production(% of total) in High income and Electricity production(% of total) in Sweden?
Make the answer very short. 33.12. In the year 2003, what is the difference between the Electricity production(% of total) of Chile and Electricity production(% of total) of Slovenia?
Provide a succinct answer. -26.54. In the year 2003, what is the difference between the Electricity production(% of total) of Chile and Electricity production(% of total) of Sweden?
Offer a very short reply. 7.34. In the year 2003, what is the difference between the Electricity production(% of total) in Slovenia and Electricity production(% of total) in Sweden?
Give a very brief answer. 33.88. In the year 2004, what is the difference between the Electricity production(% of total) in High income and Electricity production(% of total) in Chile?
Your answer should be compact. 20.17. In the year 2004, what is the difference between the Electricity production(% of total) in High income and Electricity production(% of total) in Slovenia?
Your answer should be very brief. 1.25. In the year 2004, what is the difference between the Electricity production(% of total) of High income and Electricity production(% of total) of Sweden?
Offer a very short reply. 34.04. In the year 2004, what is the difference between the Electricity production(% of total) in Chile and Electricity production(% of total) in Slovenia?
Make the answer very short. -18.92. In the year 2004, what is the difference between the Electricity production(% of total) in Chile and Electricity production(% of total) in Sweden?
Make the answer very short. 13.87. In the year 2004, what is the difference between the Electricity production(% of total) of Slovenia and Electricity production(% of total) of Sweden?
Your answer should be compact. 32.79. In the year 2005, what is the difference between the Electricity production(% of total) in High income and Electricity production(% of total) in Chile?
Provide a succinct answer. 21.23. In the year 2005, what is the difference between the Electricity production(% of total) in High income and Electricity production(% of total) in Slovenia?
Offer a very short reply. 0.1. In the year 2005, what is the difference between the Electricity production(% of total) of High income and Electricity production(% of total) of Sweden?
Your answer should be compact. 34.08. In the year 2005, what is the difference between the Electricity production(% of total) in Chile and Electricity production(% of total) in Slovenia?
Provide a short and direct response. -21.13. In the year 2005, what is the difference between the Electricity production(% of total) of Chile and Electricity production(% of total) of Sweden?
Make the answer very short. 12.85. In the year 2005, what is the difference between the Electricity production(% of total) in Slovenia and Electricity production(% of total) in Sweden?
Your answer should be very brief. 33.98. In the year 2006, what is the difference between the Electricity production(% of total) in High income and Electricity production(% of total) in Chile?
Make the answer very short. 15.46. In the year 2006, what is the difference between the Electricity production(% of total) in High income and Electricity production(% of total) in Slovenia?
Offer a terse response. -1.34. In the year 2006, what is the difference between the Electricity production(% of total) of High income and Electricity production(% of total) of Sweden?
Make the answer very short. 33.55. In the year 2006, what is the difference between the Electricity production(% of total) of Chile and Electricity production(% of total) of Slovenia?
Keep it short and to the point. -16.8. In the year 2006, what is the difference between the Electricity production(% of total) of Chile and Electricity production(% of total) of Sweden?
Your response must be concise. 18.09. In the year 2006, what is the difference between the Electricity production(% of total) in Slovenia and Electricity production(% of total) in Sweden?
Your answer should be very brief. 34.89. In the year 2007, what is the difference between the Electricity production(% of total) in High income and Electricity production(% of total) in Chile?
Offer a very short reply. 11.55. In the year 2007, what is the difference between the Electricity production(% of total) in High income and Electricity production(% of total) in Slovenia?
Your answer should be compact. -2.23. In the year 2007, what is the difference between the Electricity production(% of total) of High income and Electricity production(% of total) of Sweden?
Ensure brevity in your answer.  33.3. In the year 2007, what is the difference between the Electricity production(% of total) in Chile and Electricity production(% of total) in Slovenia?
Ensure brevity in your answer.  -13.78. In the year 2007, what is the difference between the Electricity production(% of total) in Chile and Electricity production(% of total) in Sweden?
Offer a very short reply. 21.75. In the year 2007, what is the difference between the Electricity production(% of total) in Slovenia and Electricity production(% of total) in Sweden?
Your response must be concise. 35.54. What is the ratio of the Electricity production(% of total) of High income in 2000 to that in 2001?
Provide a succinct answer. 1.02. What is the ratio of the Electricity production(% of total) of Chile in 2000 to that in 2001?
Provide a succinct answer. 1.86. What is the ratio of the Electricity production(% of total) of Slovenia in 2000 to that in 2001?
Provide a short and direct response. 1. What is the ratio of the Electricity production(% of total) in Sweden in 2000 to that in 2001?
Give a very brief answer. 0.86. What is the ratio of the Electricity production(% of total) in High income in 2000 to that in 2002?
Provide a succinct answer. 1.02. What is the ratio of the Electricity production(% of total) of Chile in 2000 to that in 2002?
Give a very brief answer. 1.83. What is the ratio of the Electricity production(% of total) of Slovenia in 2000 to that in 2002?
Your answer should be very brief. 0.93. What is the ratio of the Electricity production(% of total) in Sweden in 2000 to that in 2002?
Provide a short and direct response. 0.69. What is the ratio of the Electricity production(% of total) in Chile in 2000 to that in 2003?
Your answer should be very brief. 2.03. What is the ratio of the Electricity production(% of total) in Slovenia in 2000 to that in 2003?
Give a very brief answer. 0.92. What is the ratio of the Electricity production(% of total) in Sweden in 2000 to that in 2003?
Your answer should be very brief. 0.55. What is the ratio of the Electricity production(% of total) of High income in 2000 to that in 2004?
Keep it short and to the point. 1.03. What is the ratio of the Electricity production(% of total) in Chile in 2000 to that in 2004?
Keep it short and to the point. 1.4. What is the ratio of the Electricity production(% of total) in Slovenia in 2000 to that in 2004?
Give a very brief answer. 1. What is the ratio of the Electricity production(% of total) in Sweden in 2000 to that in 2004?
Keep it short and to the point. 1.41. What is the ratio of the Electricity production(% of total) in High income in 2000 to that in 2005?
Your answer should be very brief. 1.04. What is the ratio of the Electricity production(% of total) of Chile in 2000 to that in 2005?
Your answer should be compact. 1.54. What is the ratio of the Electricity production(% of total) in Slovenia in 2000 to that in 2005?
Ensure brevity in your answer.  0.97. What is the ratio of the Electricity production(% of total) of Sweden in 2000 to that in 2005?
Your answer should be compact. 1.91. What is the ratio of the Electricity production(% of total) in High income in 2000 to that in 2006?
Offer a very short reply. 1.05. What is the ratio of the Electricity production(% of total) of Chile in 2000 to that in 2006?
Your response must be concise. 1.1. What is the ratio of the Electricity production(% of total) of Slovenia in 2000 to that in 2006?
Make the answer very short. 0.94. What is the ratio of the Electricity production(% of total) in Sweden in 2000 to that in 2006?
Your answer should be compact. 1.58. What is the ratio of the Electricity production(% of total) of High income in 2000 to that in 2007?
Provide a short and direct response. 1.06. What is the ratio of the Electricity production(% of total) of Chile in 2000 to that in 2007?
Your response must be concise. 0.93. What is the ratio of the Electricity production(% of total) of Slovenia in 2000 to that in 2007?
Offer a very short reply. 0.93. What is the ratio of the Electricity production(% of total) of Sweden in 2000 to that in 2007?
Offer a terse response. 1.87. What is the ratio of the Electricity production(% of total) in Chile in 2001 to that in 2002?
Make the answer very short. 0.98. What is the ratio of the Electricity production(% of total) in Slovenia in 2001 to that in 2002?
Keep it short and to the point. 0.94. What is the ratio of the Electricity production(% of total) of Sweden in 2001 to that in 2002?
Your response must be concise. 0.8. What is the ratio of the Electricity production(% of total) in High income in 2001 to that in 2003?
Provide a short and direct response. 0.99. What is the ratio of the Electricity production(% of total) in Chile in 2001 to that in 2003?
Keep it short and to the point. 1.09. What is the ratio of the Electricity production(% of total) of Slovenia in 2001 to that in 2003?
Keep it short and to the point. 0.92. What is the ratio of the Electricity production(% of total) in Sweden in 2001 to that in 2003?
Make the answer very short. 0.64. What is the ratio of the Electricity production(% of total) of High income in 2001 to that in 2004?
Your answer should be compact. 1.01. What is the ratio of the Electricity production(% of total) of Chile in 2001 to that in 2004?
Provide a succinct answer. 0.75. What is the ratio of the Electricity production(% of total) of Slovenia in 2001 to that in 2004?
Your answer should be very brief. 1. What is the ratio of the Electricity production(% of total) of Sweden in 2001 to that in 2004?
Make the answer very short. 1.65. What is the ratio of the Electricity production(% of total) of High income in 2001 to that in 2005?
Your answer should be very brief. 1.02. What is the ratio of the Electricity production(% of total) of Chile in 2001 to that in 2005?
Provide a succinct answer. 0.83. What is the ratio of the Electricity production(% of total) of Slovenia in 2001 to that in 2005?
Your answer should be very brief. 0.98. What is the ratio of the Electricity production(% of total) of Sweden in 2001 to that in 2005?
Ensure brevity in your answer.  2.23. What is the ratio of the Electricity production(% of total) in High income in 2001 to that in 2006?
Your response must be concise. 1.03. What is the ratio of the Electricity production(% of total) in Chile in 2001 to that in 2006?
Keep it short and to the point. 0.59. What is the ratio of the Electricity production(% of total) of Slovenia in 2001 to that in 2006?
Ensure brevity in your answer.  0.95. What is the ratio of the Electricity production(% of total) in Sweden in 2001 to that in 2006?
Provide a succinct answer. 1.85. What is the ratio of the Electricity production(% of total) in High income in 2001 to that in 2007?
Offer a terse response. 1.04. What is the ratio of the Electricity production(% of total) of Chile in 2001 to that in 2007?
Provide a succinct answer. 0.5. What is the ratio of the Electricity production(% of total) in Slovenia in 2001 to that in 2007?
Your answer should be compact. 0.93. What is the ratio of the Electricity production(% of total) in Sweden in 2001 to that in 2007?
Make the answer very short. 2.18. What is the ratio of the Electricity production(% of total) in High income in 2002 to that in 2003?
Ensure brevity in your answer.  0.98. What is the ratio of the Electricity production(% of total) in Chile in 2002 to that in 2003?
Make the answer very short. 1.11. What is the ratio of the Electricity production(% of total) of Slovenia in 2002 to that in 2003?
Provide a short and direct response. 0.98. What is the ratio of the Electricity production(% of total) in Sweden in 2002 to that in 2003?
Keep it short and to the point. 0.81. What is the ratio of the Electricity production(% of total) of High income in 2002 to that in 2004?
Make the answer very short. 1.01. What is the ratio of the Electricity production(% of total) in Chile in 2002 to that in 2004?
Your answer should be compact. 0.77. What is the ratio of the Electricity production(% of total) of Slovenia in 2002 to that in 2004?
Provide a succinct answer. 1.07. What is the ratio of the Electricity production(% of total) of Sweden in 2002 to that in 2004?
Offer a terse response. 2.06. What is the ratio of the Electricity production(% of total) in High income in 2002 to that in 2005?
Make the answer very short. 1.02. What is the ratio of the Electricity production(% of total) in Chile in 2002 to that in 2005?
Provide a short and direct response. 0.84. What is the ratio of the Electricity production(% of total) of Slovenia in 2002 to that in 2005?
Make the answer very short. 1.04. What is the ratio of the Electricity production(% of total) in Sweden in 2002 to that in 2005?
Offer a very short reply. 2.79. What is the ratio of the Electricity production(% of total) in Chile in 2002 to that in 2006?
Ensure brevity in your answer.  0.6. What is the ratio of the Electricity production(% of total) in Slovenia in 2002 to that in 2006?
Provide a short and direct response. 1.01. What is the ratio of the Electricity production(% of total) in Sweden in 2002 to that in 2006?
Ensure brevity in your answer.  2.31. What is the ratio of the Electricity production(% of total) of High income in 2002 to that in 2007?
Keep it short and to the point. 1.04. What is the ratio of the Electricity production(% of total) in Chile in 2002 to that in 2007?
Your answer should be very brief. 0.51. What is the ratio of the Electricity production(% of total) in Slovenia in 2002 to that in 2007?
Give a very brief answer. 1. What is the ratio of the Electricity production(% of total) in Sweden in 2002 to that in 2007?
Your response must be concise. 2.73. What is the ratio of the Electricity production(% of total) in High income in 2003 to that in 2004?
Your response must be concise. 1.03. What is the ratio of the Electricity production(% of total) in Chile in 2003 to that in 2004?
Offer a terse response. 0.69. What is the ratio of the Electricity production(% of total) of Slovenia in 2003 to that in 2004?
Provide a succinct answer. 1.09. What is the ratio of the Electricity production(% of total) in Sweden in 2003 to that in 2004?
Make the answer very short. 2.56. What is the ratio of the Electricity production(% of total) in High income in 2003 to that in 2005?
Keep it short and to the point. 1.03. What is the ratio of the Electricity production(% of total) of Chile in 2003 to that in 2005?
Give a very brief answer. 0.76. What is the ratio of the Electricity production(% of total) in Slovenia in 2003 to that in 2005?
Keep it short and to the point. 1.06. What is the ratio of the Electricity production(% of total) of Sweden in 2003 to that in 2005?
Offer a terse response. 3.47. What is the ratio of the Electricity production(% of total) in High income in 2003 to that in 2006?
Make the answer very short. 1.05. What is the ratio of the Electricity production(% of total) of Chile in 2003 to that in 2006?
Your answer should be very brief. 0.54. What is the ratio of the Electricity production(% of total) in Slovenia in 2003 to that in 2006?
Ensure brevity in your answer.  1.03. What is the ratio of the Electricity production(% of total) in Sweden in 2003 to that in 2006?
Your response must be concise. 2.87. What is the ratio of the Electricity production(% of total) in High income in 2003 to that in 2007?
Your answer should be compact. 1.06. What is the ratio of the Electricity production(% of total) of Chile in 2003 to that in 2007?
Provide a short and direct response. 0.46. What is the ratio of the Electricity production(% of total) in Slovenia in 2003 to that in 2007?
Make the answer very short. 1.01. What is the ratio of the Electricity production(% of total) of Sweden in 2003 to that in 2007?
Your answer should be compact. 3.39. What is the ratio of the Electricity production(% of total) in High income in 2004 to that in 2005?
Your answer should be compact. 1.01. What is the ratio of the Electricity production(% of total) of Chile in 2004 to that in 2005?
Your answer should be very brief. 1.1. What is the ratio of the Electricity production(% of total) of Slovenia in 2004 to that in 2005?
Keep it short and to the point. 0.97. What is the ratio of the Electricity production(% of total) of Sweden in 2004 to that in 2005?
Your answer should be very brief. 1.35. What is the ratio of the Electricity production(% of total) in High income in 2004 to that in 2006?
Provide a short and direct response. 1.02. What is the ratio of the Electricity production(% of total) in Chile in 2004 to that in 2006?
Provide a succinct answer. 0.79. What is the ratio of the Electricity production(% of total) of Slovenia in 2004 to that in 2006?
Provide a succinct answer. 0.95. What is the ratio of the Electricity production(% of total) in Sweden in 2004 to that in 2006?
Make the answer very short. 1.12. What is the ratio of the Electricity production(% of total) in High income in 2004 to that in 2007?
Provide a short and direct response. 1.03. What is the ratio of the Electricity production(% of total) of Chile in 2004 to that in 2007?
Your answer should be compact. 0.67. What is the ratio of the Electricity production(% of total) of Slovenia in 2004 to that in 2007?
Provide a short and direct response. 0.93. What is the ratio of the Electricity production(% of total) of Sweden in 2004 to that in 2007?
Offer a terse response. 1.32. What is the ratio of the Electricity production(% of total) of Chile in 2005 to that in 2006?
Provide a succinct answer. 0.72. What is the ratio of the Electricity production(% of total) of Slovenia in 2005 to that in 2006?
Your answer should be compact. 0.97. What is the ratio of the Electricity production(% of total) in Sweden in 2005 to that in 2006?
Your response must be concise. 0.83. What is the ratio of the Electricity production(% of total) of High income in 2005 to that in 2007?
Ensure brevity in your answer.  1.02. What is the ratio of the Electricity production(% of total) in Chile in 2005 to that in 2007?
Give a very brief answer. 0.61. What is the ratio of the Electricity production(% of total) in Slovenia in 2005 to that in 2007?
Offer a terse response. 0.96. What is the ratio of the Electricity production(% of total) of High income in 2006 to that in 2007?
Make the answer very short. 1.01. What is the ratio of the Electricity production(% of total) of Chile in 2006 to that in 2007?
Keep it short and to the point. 0.85. What is the ratio of the Electricity production(% of total) of Slovenia in 2006 to that in 2007?
Make the answer very short. 0.99. What is the ratio of the Electricity production(% of total) in Sweden in 2006 to that in 2007?
Give a very brief answer. 1.18. What is the difference between the highest and the second highest Electricity production(% of total) of High income?
Ensure brevity in your answer.  0.14. What is the difference between the highest and the second highest Electricity production(% of total) in Chile?
Your answer should be very brief. 1.54. What is the difference between the highest and the second highest Electricity production(% of total) in Slovenia?
Provide a succinct answer. 0.52. What is the difference between the highest and the second highest Electricity production(% of total) of Sweden?
Offer a very short reply. 0.6. What is the difference between the highest and the lowest Electricity production(% of total) in High income?
Ensure brevity in your answer.  2.13. What is the difference between the highest and the lowest Electricity production(% of total) in Chile?
Give a very brief answer. 12.24. What is the difference between the highest and the lowest Electricity production(% of total) of Slovenia?
Offer a terse response. 3.12. What is the difference between the highest and the lowest Electricity production(% of total) in Sweden?
Your answer should be very brief. 2.19. 